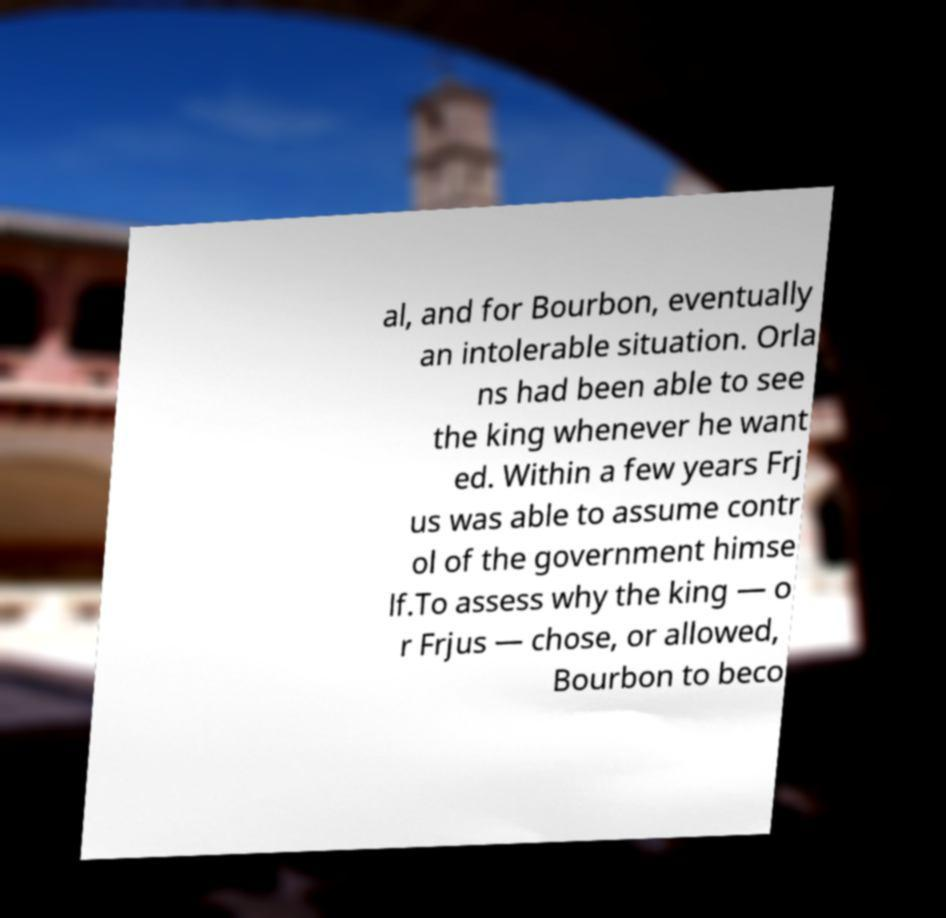Could you extract and type out the text from this image? al, and for Bourbon, eventually an intolerable situation. Orla ns had been able to see the king whenever he want ed. Within a few years Frj us was able to assume contr ol of the government himse lf.To assess why the king — o r Frjus — chose, or allowed, Bourbon to beco 